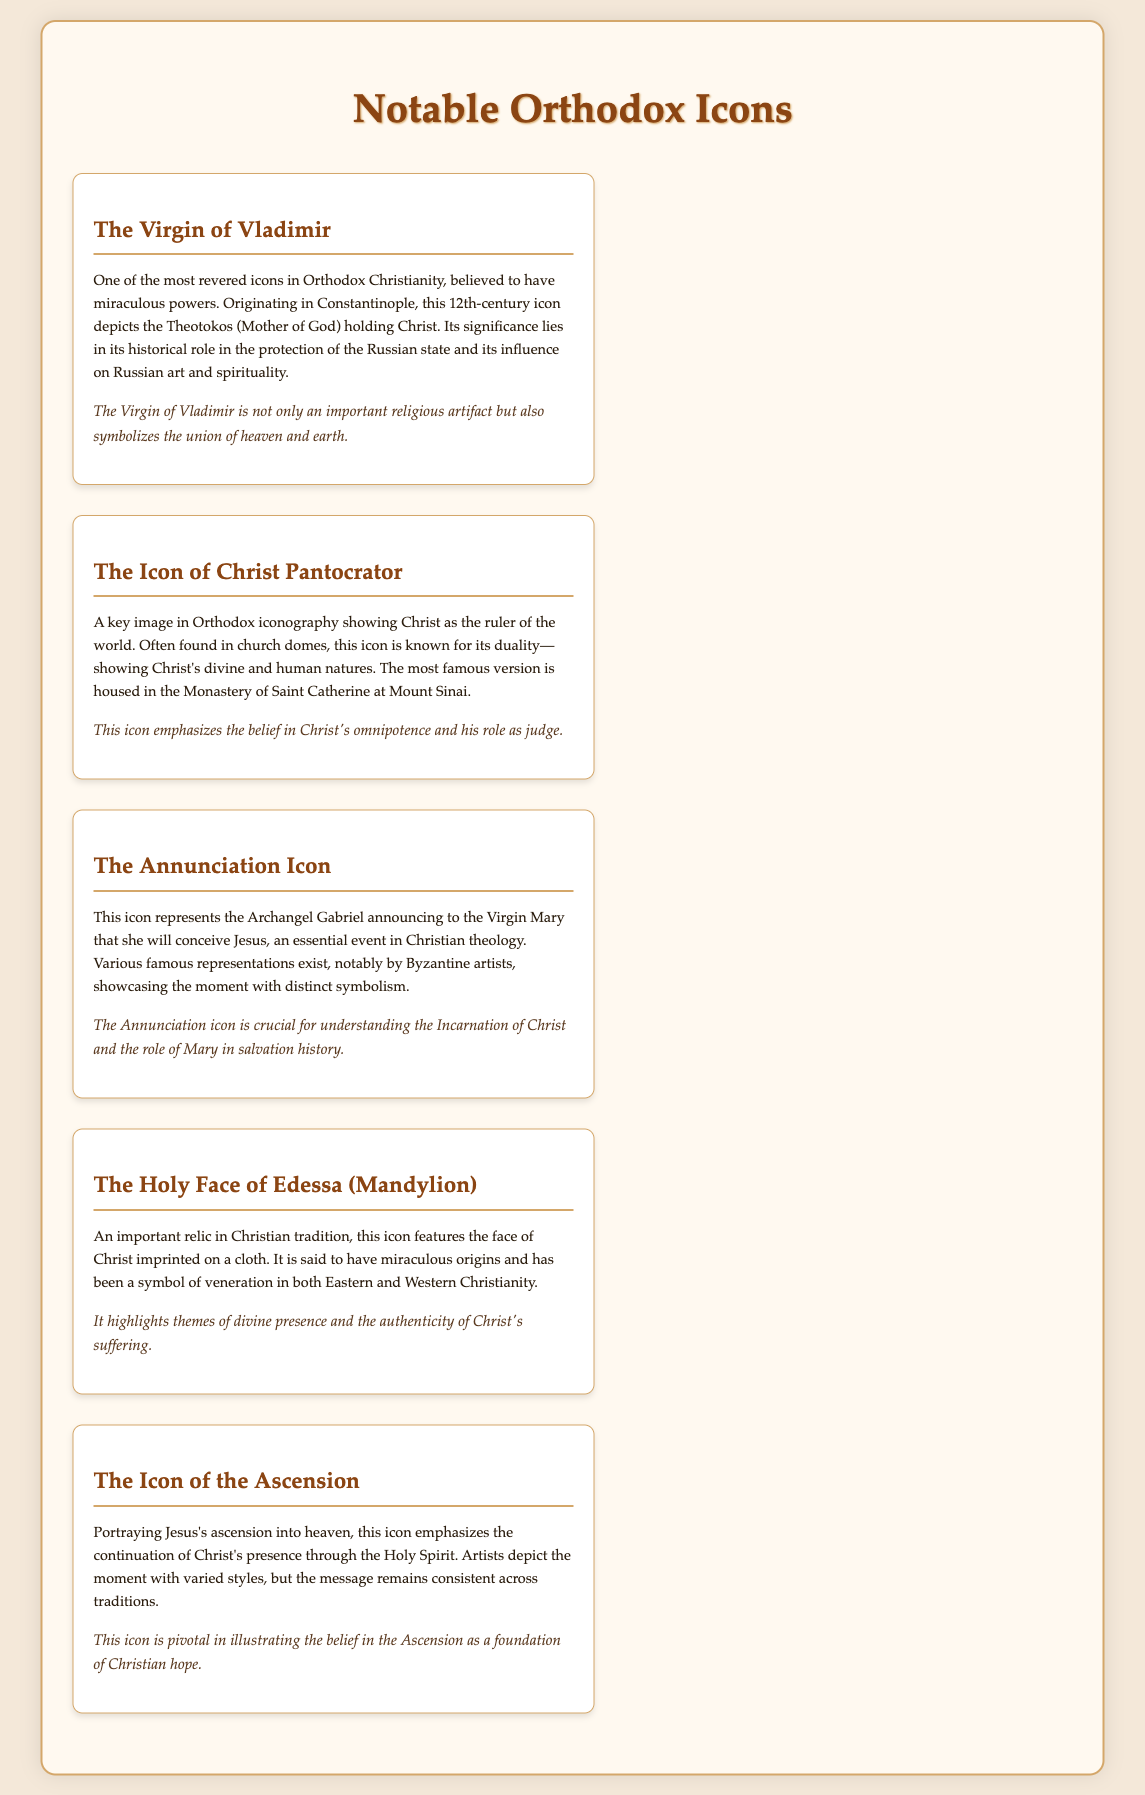what is the title of the first icon listed? The title of the first icon listed is found in the first icon item, which is "The Virgin of Vladimir."
Answer: The Virgin of Vladimir which century does the Virgin of Vladimir icon originate from? The origin of the Virgin of Vladimir icon is mentioned in the description, specifically stating it is from the 12th century.
Answer: 12th century who announced to the Virgin Mary according to the Annunciation Icon? The document specifies that the Archangel Gabriel is the one who announces to the Virgin Mary in the Annunciation Icon.
Answer: Archangel Gabriel what is depicted in the Icon of the Ascension? The Icon of the Ascension portrays a specific event, which is Jesus's ascension into heaven as described in the icon description.
Answer: Jesus's ascension into heaven what is the significance of the Holy Face of Edessa? The significance of the Holy Face of Edessa is detailed in the icon's description, highlighting themes of divine presence and Christ's suffering.
Answer: Divine presence and the authenticity of Christ's suffering where is the most famous version of the Icon of Christ Pantocrator housed? The famous version of the Icon of Christ Pantocrator is mentioned to be housed in a specific location, which is the Monastery of Saint Catherine at Mount Sinai.
Answer: Monastery of Saint Catherine at Mount Sinai 